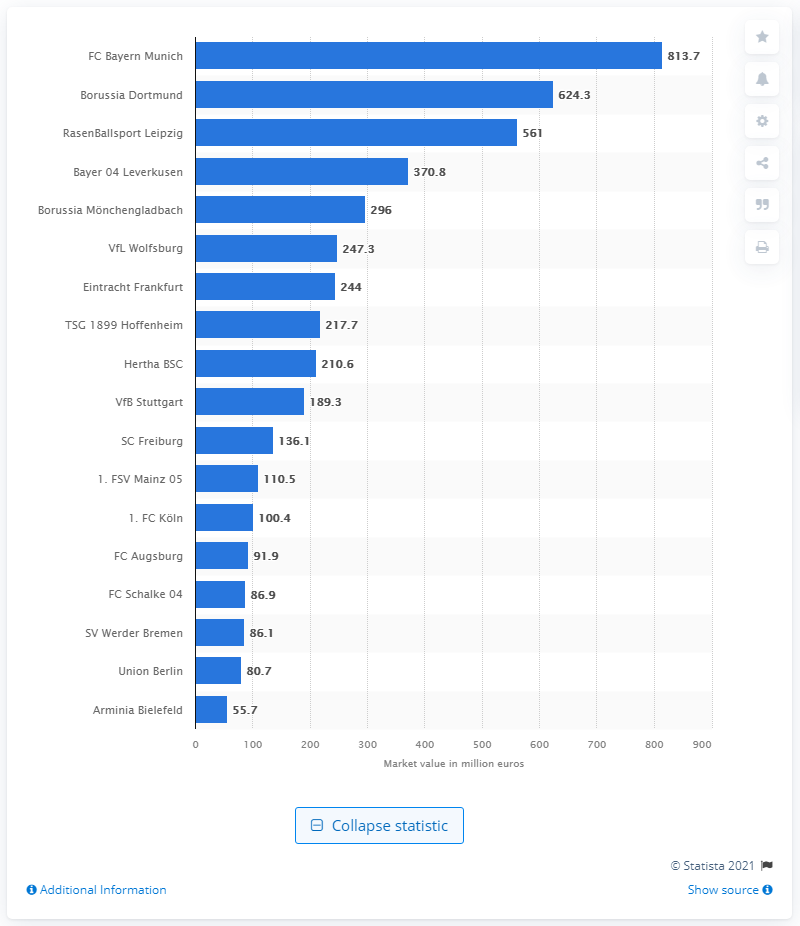Give some essential details in this illustration. The market value of FC Bayern Munich was 813.7 million. The market value of Borussia Dortmund was approximately 624.3 million USD. 